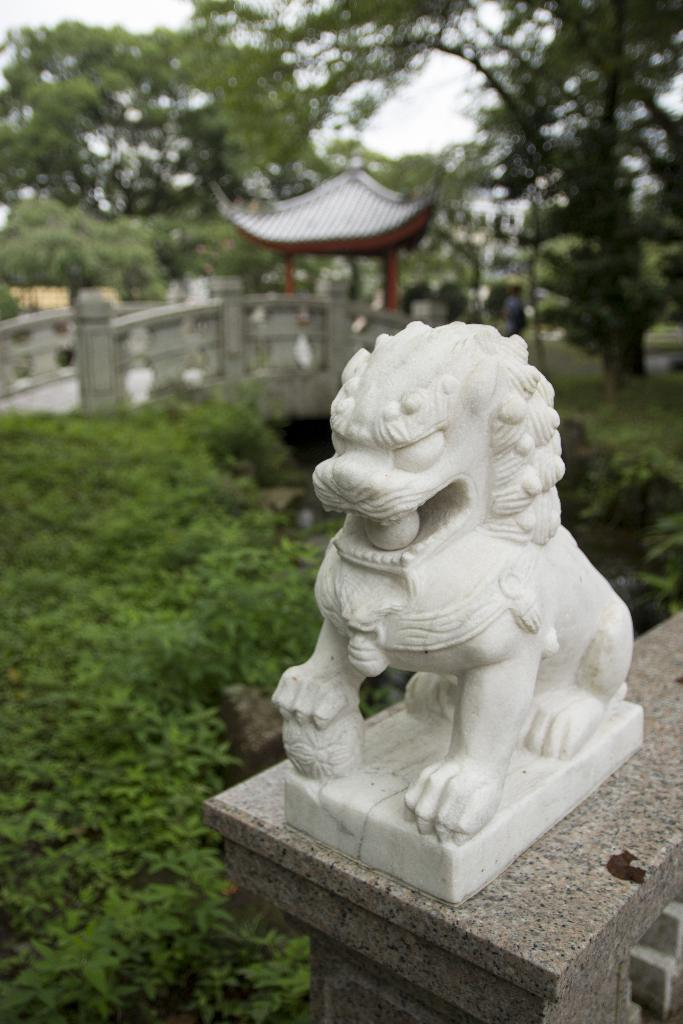What is the main subject in the image? There is a white statue in the image. What can be seen in the background of the image? In the background of the image, there are plants, a bridge, a roof, pillars, trees, and the sky. Can you describe the setting of the image? The image appears to be set in an outdoor area with a statue surrounded by various structures and natural elements. What type of bait is being used by the beetle in the image? There is no beetle or bait present in the image; it features a white statue surrounded by various structures and natural elements. 